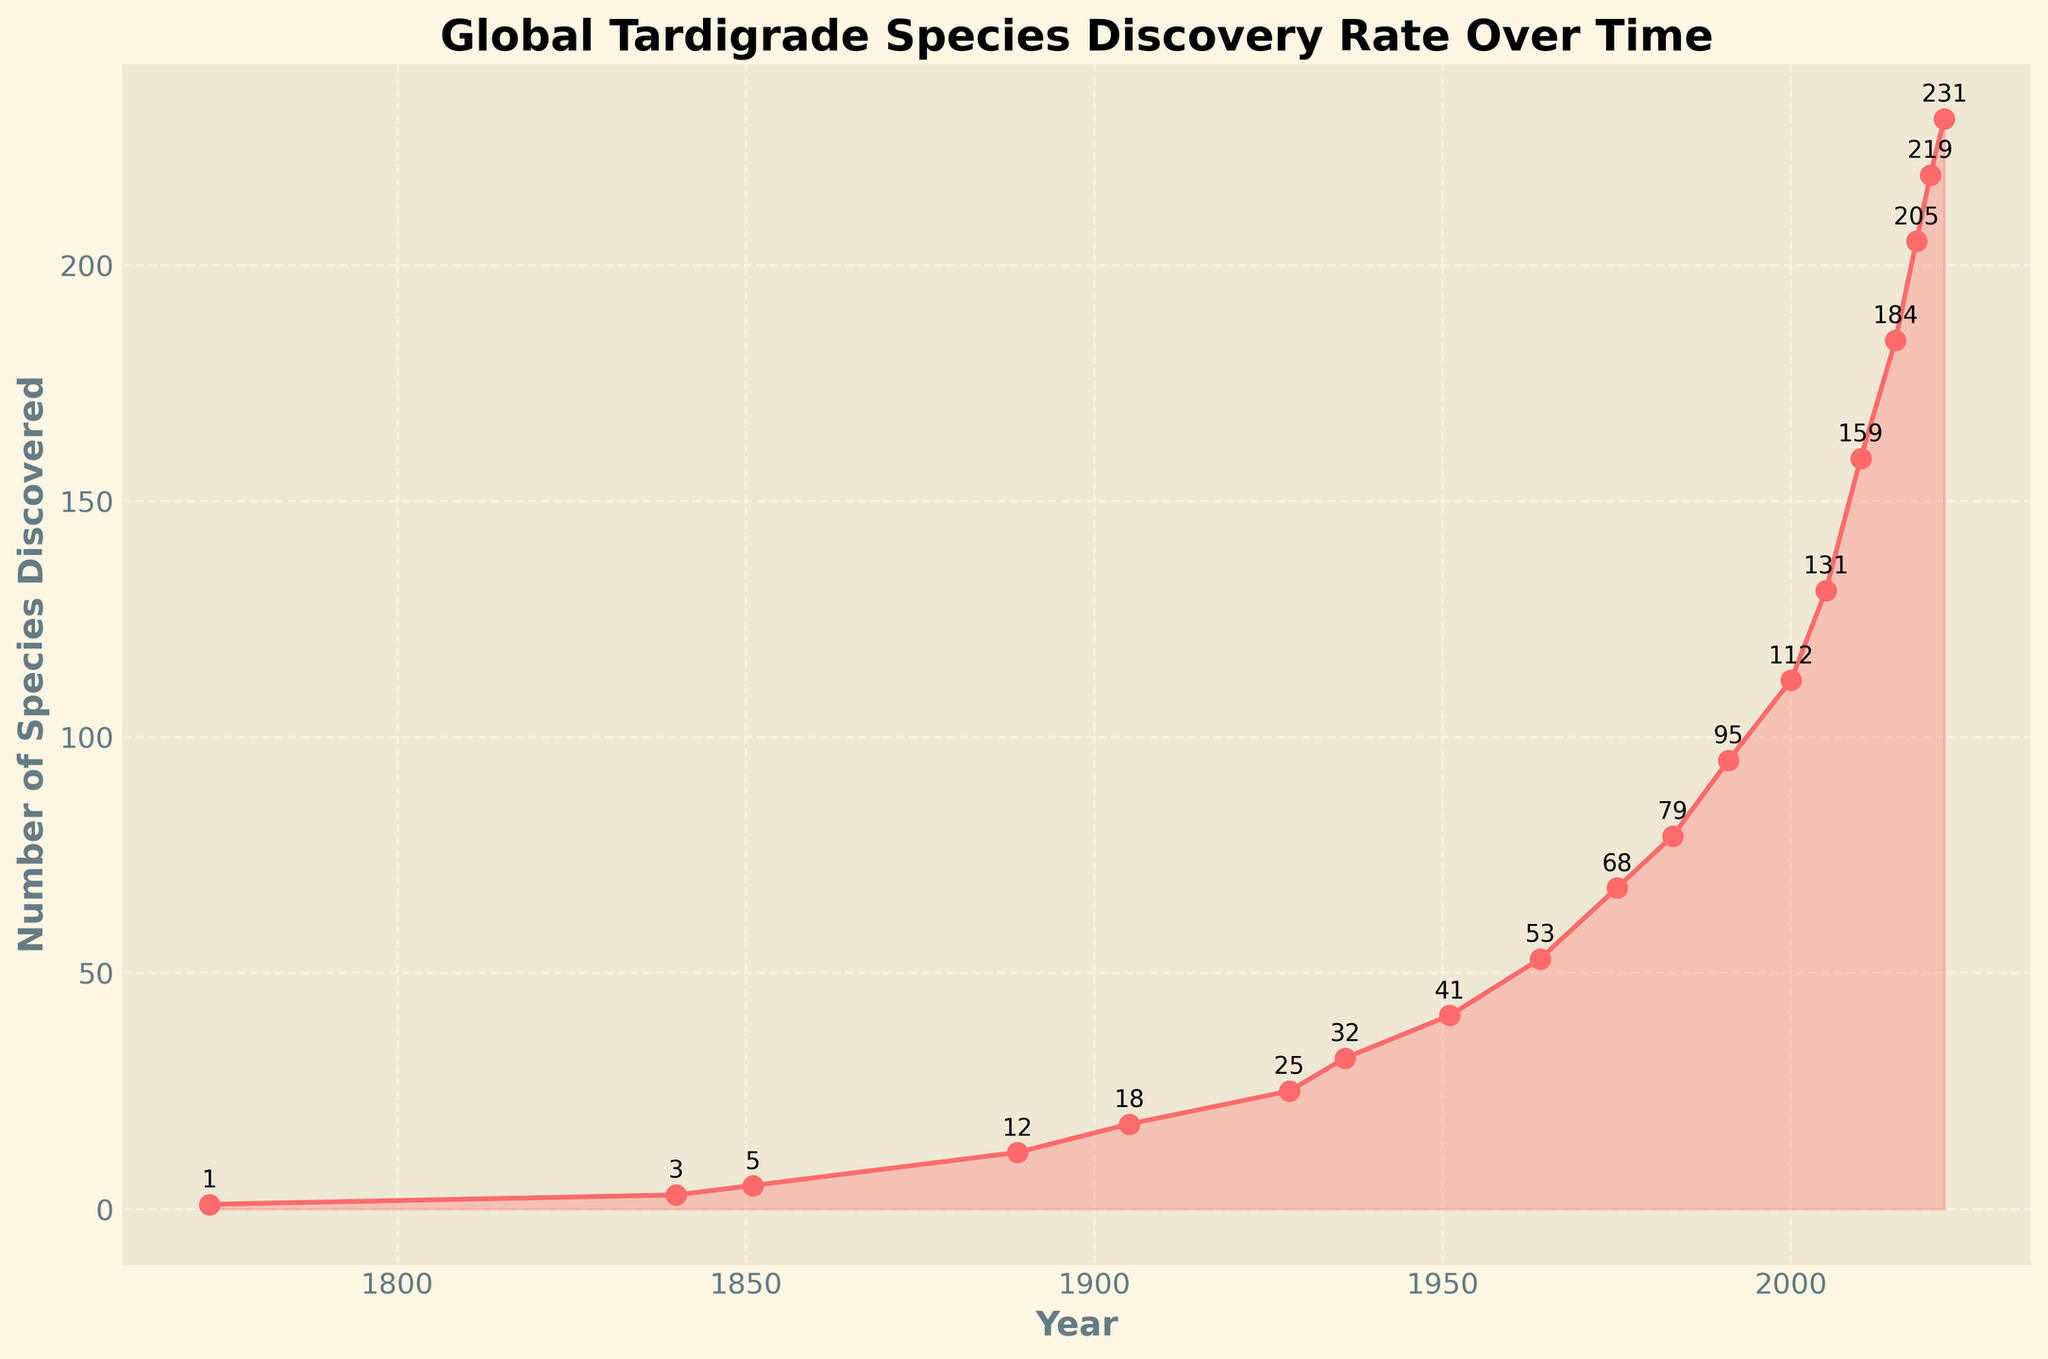What is the total number of tardigrade species discovered by 2022? From the figure, the y-axis shows the number of species discovered in each year. By the year 2022, the number of species discovered is given as 231.
Answer: 231 Between which years did the number of discovered tardigrade species increase the most? To find the largest increase, identify the steepest slope on the line graph. Comparing the differences: 2010 to 2015 (159 to 184 = 25), 2005 to 2010 (131 to 159 = 28). The largest increase is 2005 to 2010.
Answer: 2005 to 2010 What was the increase in the number of species discovered from 1889 to 1928? In 1889, 12 species were discovered. By 1928, 25 species were discovered. So the increase is 25 - 12 = 13.
Answer: 13 How many species were discovered between 2000 and 2015? The number of species discovered in 2000 was 112, and in 2015 it was 184. Therefore, the number of species discovered between these years is 184 - 112 = 72.
Answer: 72 Which period saw a greater increase in the number of species discovered: 1936 to 1951 or 1991 to 2000? From 1936 to 1951, the increase is 41 - 32 = 9. From 1991 to 2000, the increase is 112 - 95 = 17. Comparing these, the period 1991 to 2000 saw the greater increase.
Answer: 1991 to 2000 What is the average number of species discovered per decade between 1975 and 2022? From 1975 to 2022, 68 species in 1975 to 231 species in 2022. So, total species discovered = 231 - 68 = 163. There are about 4.7 decades in this span (47 years), so the average is 163 / 4.7 ≈ 34.7.
Answer: 34.7 Describe the trend of tardigrade species discovery over time visually. The line graph shows a generally increasing trend in the discovery rate of tardigrade species over time. The steepness of the slope varies, indicating fluctuating rates of discovery across different periods, with significant increases around 2000 and beyond.
Answer: Increasing trend By how many species did discoveries increase between the two peaks from 2015 to 2022? The number of species discovered in 2015 was 184, and in 2022 it was 231. Therefore, the increase is 231 - 184 = 47 species.
Answer: 47 